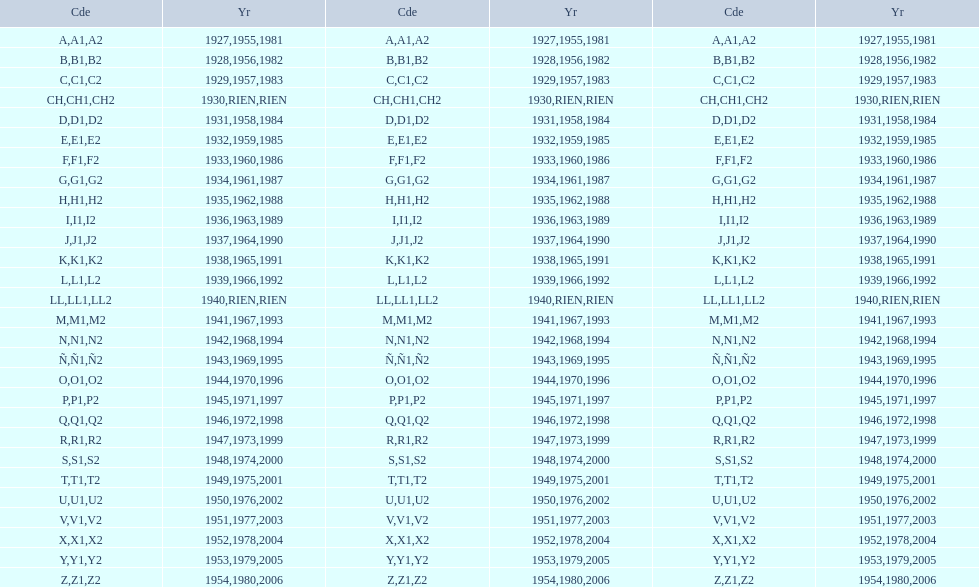What was the only year to use the code ch? 1930. 